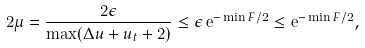<formula> <loc_0><loc_0><loc_500><loc_500>2 \mu = \frac { 2 \epsilon } { \max ( \Delta u + u _ { t } + 2 ) } \leq \epsilon \, \mathrm e ^ { - \min F / 2 } \leq \mathrm e ^ { - \min F / 2 } ,</formula> 